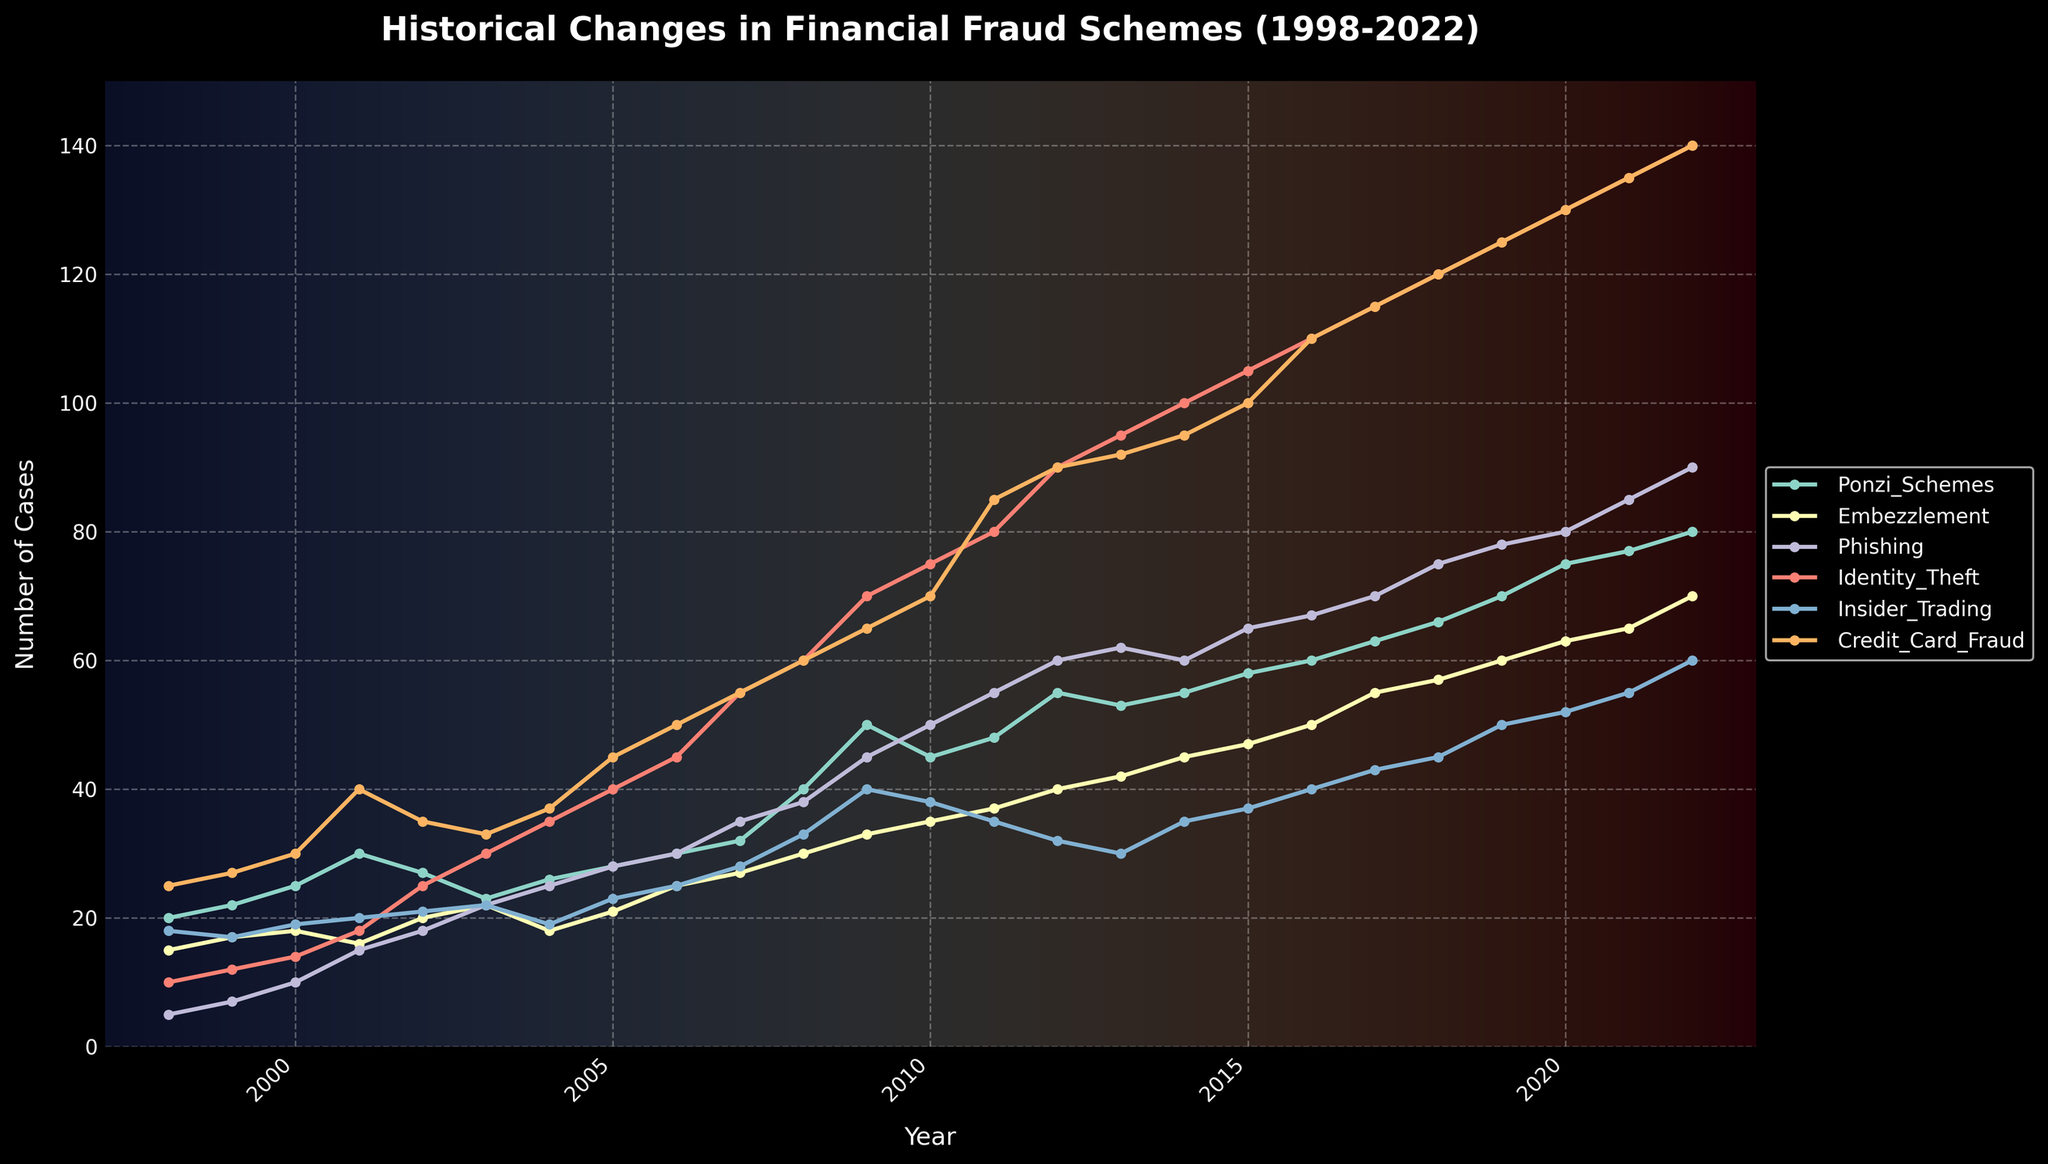What is the title of the figure? The title of the figure is prominently displayed at the top of the plot, typically in a larger font and bold formatting, indicating the main topic of the visualization. The exact wording is located there.
Answer: Historical Changes in Financial Fraud Schemes (1998-2022) What are the six types of financial fraud schemes shown in the plot? The legend on the right side of the plot lists all the different types of financial fraud schemes by their labels. These labels correspond to the lines representing each type of fraud.
Answer: Ponzi Schemes, Embezzlement, Phishing, Identity Theft, Insider Trading, Credit Card Fraud Which fraud scheme shows the highest number of cases in 2022? To determine this, look at the data points on the right end of each line corresponding to the year 2022. The highest point will indicate the scheme with the most cases.
Answer: Identity Theft How many cases of Ponzi Schemes were reported in 2010? Locate the Ponzi Schemes line on the figure and find the data point that corresponds to the year 2010. Read the number of cases that aligns with this point on the y-axis.
Answer: 45 Did Insider Trading cases increase or decrease between 2012 and 2014? Observe the Insider Trading line between the years 2012 and 2014. A line moving upwards indicates an increase, while a line moving downwards indicates a decrease.
Answer: Decrease What is the overall trend of Credit Card Fraud from 1998 to 2022? Examine the trajectory of the Credit Card Fraud line throughout the years from the start to the end of the plot. A consistently rising line indicates an upward trend, while a fluctuating line might suggest variations in trend.
Answer: Increasing Which fraud scheme had the least number of cases in 2001 and how many cases were there? Identify the data points for the year 2001 for all the fraud schemes and find out which one has the lowest position on the y-axis.
Answer: Phishing with 15 cases By how much did Identity Theft cases increase from 1998 to 2008? Find the value of Identity Theft cases in 1998 and in 2008 from the plot. Subtract the former from the latter to find the increase. In 1998, there were 10 cases and in 2008, there were 60 cases: 60 - 10 = 50.
Answer: 50 Which fraud scheme saw the most significant rise in the number of cases from 1998 to 2022? To determine the most significant rise, compare the starting and ending points of all the lines, noting the difference. The largest difference indicates the most significant rise.
Answer: Identity Theft During which year did Phishing cases surpass Embezzlement cases for the first time? To address this, track the lines representing Phishing and Embezzlement and note the first year where the Phishing line crosses above the Embezzlement line.
Answer: 2004 